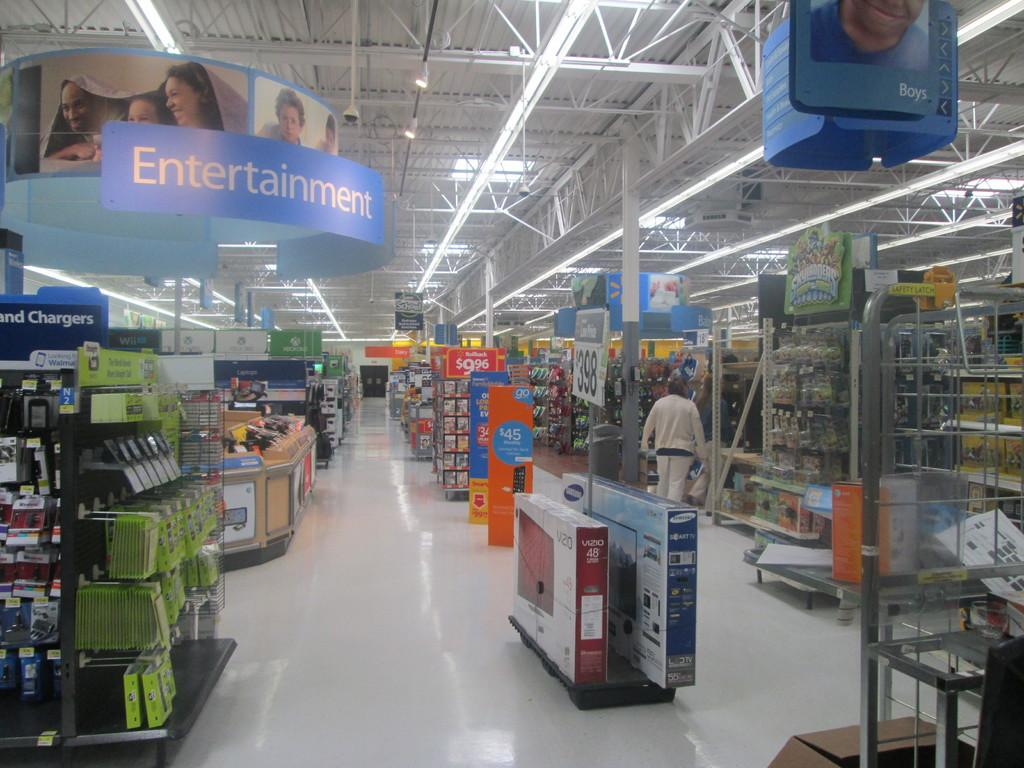<image>
Write a terse but informative summary of the picture. A store that also has an entertainment section. 